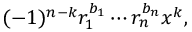Convert formula to latex. <formula><loc_0><loc_0><loc_500><loc_500>( - 1 ) ^ { n - k } r _ { 1 } ^ { b _ { 1 } } \cdots r _ { n } ^ { b _ { n } } x ^ { k } ,</formula> 